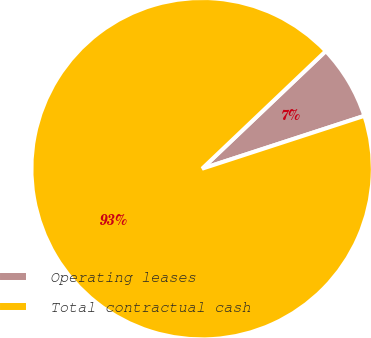<chart> <loc_0><loc_0><loc_500><loc_500><pie_chart><fcel>Operating leases<fcel>Total contractual cash<nl><fcel>7.09%<fcel>92.91%<nl></chart> 